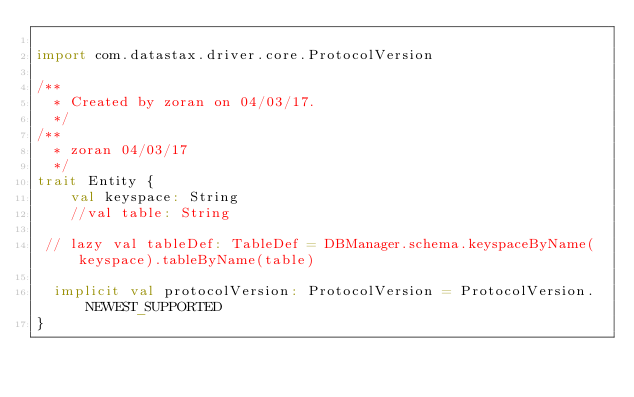<code> <loc_0><loc_0><loc_500><loc_500><_Scala_>
import com.datastax.driver.core.ProtocolVersion

/**
  * Created by zoran on 04/03/17.
  */
/**
  * zoran 04/03/17
  */
trait Entity {
    val keyspace: String
    //val table: String

 // lazy val tableDef: TableDef = DBManager.schema.keyspaceByName(keyspace).tableByName(table)

  implicit val protocolVersion: ProtocolVersion = ProtocolVersion.NEWEST_SUPPORTED
}
</code> 